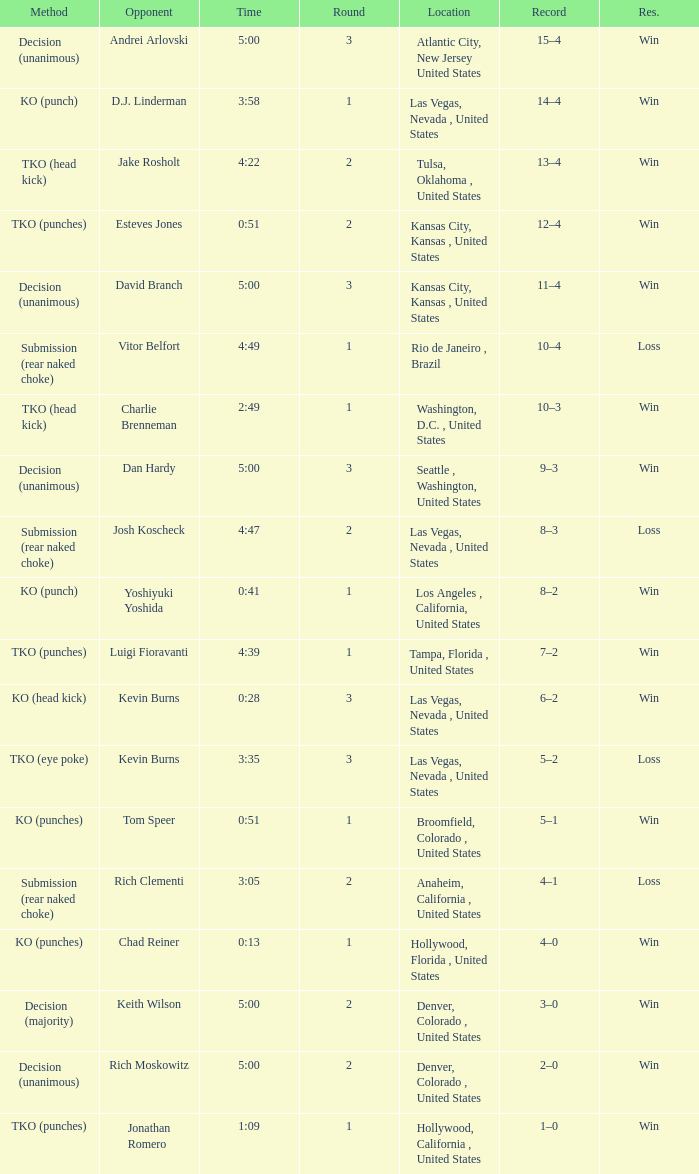What is the result for rounds under 2 against D.J. Linderman? Win. 